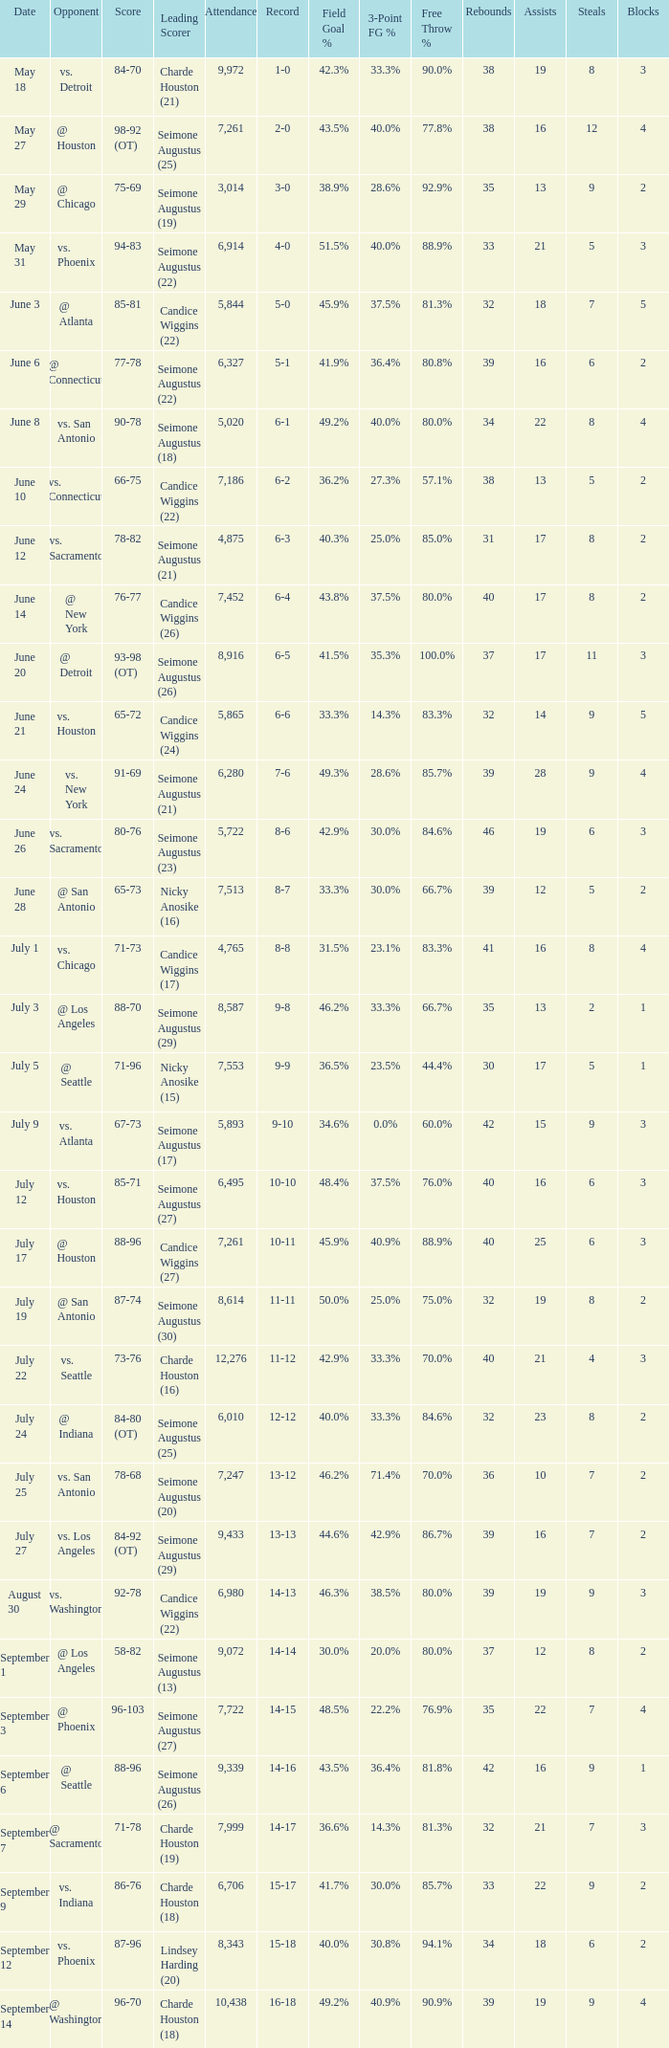Help me parse the entirety of this table. {'header': ['Date', 'Opponent', 'Score', 'Leading Scorer', 'Attendance', 'Record', 'Field Goal %', '3-Point FG %', 'Free Throw %', 'Rebounds', 'Assists', 'Steals', 'Blocks'], 'rows': [['May 18', 'vs. Detroit', '84-70', 'Charde Houston (21)', '9,972', '1-0', '42.3%', '33.3%', '90.0%', '38', '19', '8', '3'], ['May 27', '@ Houston', '98-92 (OT)', 'Seimone Augustus (25)', '7,261', '2-0', '43.5%', '40.0%', '77.8%', '38', '16', '12', '4'], ['May 29', '@ Chicago', '75-69', 'Seimone Augustus (19)', '3,014', '3-0', '38.9%', '28.6%', '92.9%', '35', '13', '9', '2'], ['May 31', 'vs. Phoenix', '94-83', 'Seimone Augustus (22)', '6,914', '4-0', '51.5%', '40.0%', '88.9%', '33', '21', '5', '3'], ['June 3', '@ Atlanta', '85-81', 'Candice Wiggins (22)', '5,844', '5-0', '45.9%', '37.5%', '81.3%', '32', '18', '7', '5'], ['June 6', '@ Connecticut', '77-78', 'Seimone Augustus (22)', '6,327', '5-1', '41.9%', '36.4%', '80.8%', '39', '16', '6', '2'], ['June 8', 'vs. San Antonio', '90-78', 'Seimone Augustus (18)', '5,020', '6-1', '49.2%', '40.0%', '80.0%', '34', '22', '8', '4'], ['June 10', 'vs. Connecticut', '66-75', 'Candice Wiggins (22)', '7,186', '6-2', '36.2%', '27.3%', '57.1%', '38', '13', '5', '2'], ['June 12', 'vs. Sacramento', '78-82', 'Seimone Augustus (21)', '4,875', '6-3', '40.3%', '25.0%', '85.0%', '31', '17', '8', '2'], ['June 14', '@ New York', '76-77', 'Candice Wiggins (26)', '7,452', '6-4', '43.8%', '37.5%', '80.0%', '40', '17', '8', '2'], ['June 20', '@ Detroit', '93-98 (OT)', 'Seimone Augustus (26)', '8,916', '6-5', '41.5%', '35.3%', '100.0%', '37', '17', '11', '3'], ['June 21', 'vs. Houston', '65-72', 'Candice Wiggins (24)', '5,865', '6-6', '33.3%', '14.3%', '83.3%', '32', '14', '9', '5'], ['June 24', 'vs. New York', '91-69', 'Seimone Augustus (21)', '6,280', '7-6', '49.3%', '28.6%', '85.7%', '39', '28', '9', '4'], ['June 26', 'vs. Sacramento', '80-76', 'Seimone Augustus (23)', '5,722', '8-6', '42.9%', '30.0%', '84.6%', '46', '19', '6', '3'], ['June 28', '@ San Antonio', '65-73', 'Nicky Anosike (16)', '7,513', '8-7', '33.3%', '30.0%', '66.7%', '39', '12', '5', '2'], ['July 1', 'vs. Chicago', '71-73', 'Candice Wiggins (17)', '4,765', '8-8', '31.5%', '23.1%', '83.3%', '41', '16', '8', '4'], ['July 3', '@ Los Angeles', '88-70', 'Seimone Augustus (29)', '8,587', '9-8', '46.2%', '33.3%', '66.7%', '35', '13', '2', '1'], ['July 5', '@ Seattle', '71-96', 'Nicky Anosike (15)', '7,553', '9-9', '36.5%', '23.5%', '44.4%', '30', '17', '5', '1'], ['July 9', 'vs. Atlanta', '67-73', 'Seimone Augustus (17)', '5,893', '9-10', '34.6%', '0.0%', '60.0%', '42', '15', '9', '3'], ['July 12', 'vs. Houston', '85-71', 'Seimone Augustus (27)', '6,495', '10-10', '48.4%', '37.5%', '76.0%', '40', '16', '6', '3'], ['July 17', '@ Houston', '88-96', 'Candice Wiggins (27)', '7,261', '10-11', '45.9%', '40.9%', '88.9%', '40', '25', '6', '3'], ['July 19', '@ San Antonio', '87-74', 'Seimone Augustus (30)', '8,614', '11-11', '50.0%', '25.0%', '75.0%', '32', '19', '8', '2'], ['July 22', 'vs. Seattle', '73-76', 'Charde Houston (16)', '12,276', '11-12', '42.9%', '33.3%', '70.0%', '40', '21', '4', '3'], ['July 24', '@ Indiana', '84-80 (OT)', 'Seimone Augustus (25)', '6,010', '12-12', '40.0%', '33.3%', '84.6%', '32', '23', '8', '2'], ['July 25', 'vs. San Antonio', '78-68', 'Seimone Augustus (20)', '7,247', '13-12', '46.2%', '71.4%', '70.0%', '36', '10', '7', '2'], ['July 27', 'vs. Los Angeles', '84-92 (OT)', 'Seimone Augustus (29)', '9,433', '13-13', '44.6%', '42.9%', '86.7%', '39', '16', '7', '2'], ['August 30', 'vs. Washington', '92-78', 'Candice Wiggins (22)', '6,980', '14-13', '46.3%', '38.5%', '80.0%', '39', '19', '9', '3'], ['September 1', '@ Los Angeles', '58-82', 'Seimone Augustus (13)', '9,072', '14-14', '30.0%', '20.0%', '80.0%', '37', '12', '8', '2'], ['September 3', '@ Phoenix', '96-103', 'Seimone Augustus (27)', '7,722', '14-15', '48.5%', '22.2%', '76.9%', '35', '22', '7', '4'], ['September 6', '@ Seattle', '88-96', 'Seimone Augustus (26)', '9,339', '14-16', '43.5%', '36.4%', '81.8%', '42', '16', '9', '1'], ['September 7', '@ Sacramento', '71-78', 'Charde Houston (19)', '7,999', '14-17', '36.6%', '14.3%', '81.3%', '32', '21', '7', '3'], ['September 9', 'vs. Indiana', '86-76', 'Charde Houston (18)', '6,706', '15-17', '41.7%', '30.0%', '85.7%', '33', '22', '9', '2'], ['September 12', 'vs. Phoenix', '87-96', 'Lindsey Harding (20)', '8,343', '15-18', '40.0%', '30.8%', '94.1%', '34', '18', '6', '2'], ['September 14', '@ Washington', '96-70', 'Charde Houston (18)', '10,438', '16-18', '49.2%', '40.9%', '90.9%', '39', '19', '9', '4']]} Which Attendance has a Date of september 7? 7999.0. 